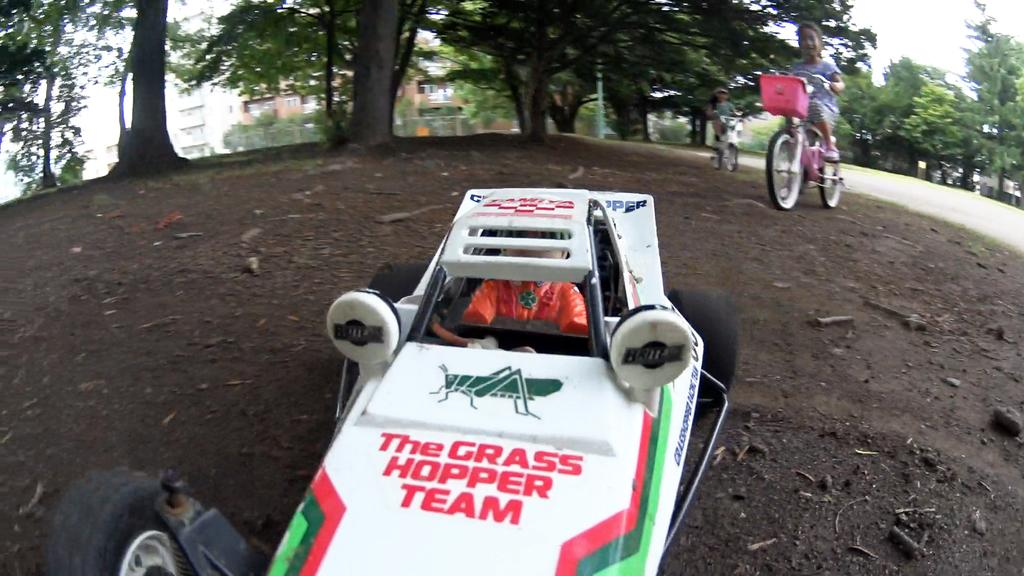What is the main subject of the image? The main subject of the image is a car. Where is the car located in the image? The car is on the floor in the image. What are the two kids doing in the image? The two kids are riding bicycles in the image. What type of natural elements can be seen in the image? There are trees and plants in the image. What type of marble is being used to decorate the car in the image? There is no marble present in the image; the car is simply located on the floor. 